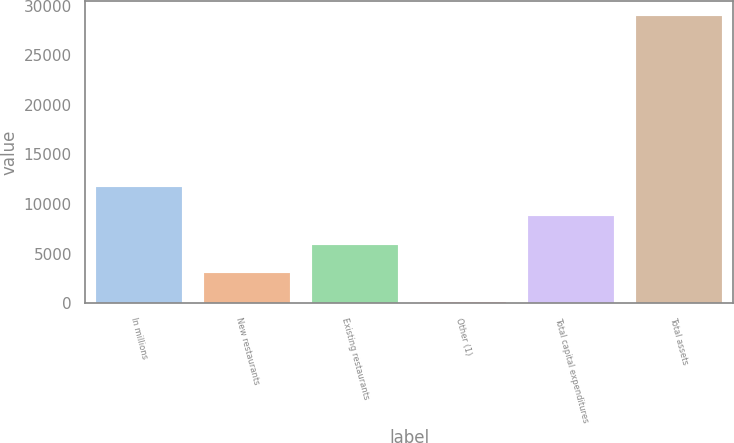<chart> <loc_0><loc_0><loc_500><loc_500><bar_chart><fcel>In millions<fcel>New restaurants<fcel>Existing restaurants<fcel>Other (1)<fcel>Total capital expenditures<fcel>Total assets<nl><fcel>11671.8<fcel>3020.7<fcel>5904.4<fcel>137<fcel>8788.1<fcel>28974<nl></chart> 